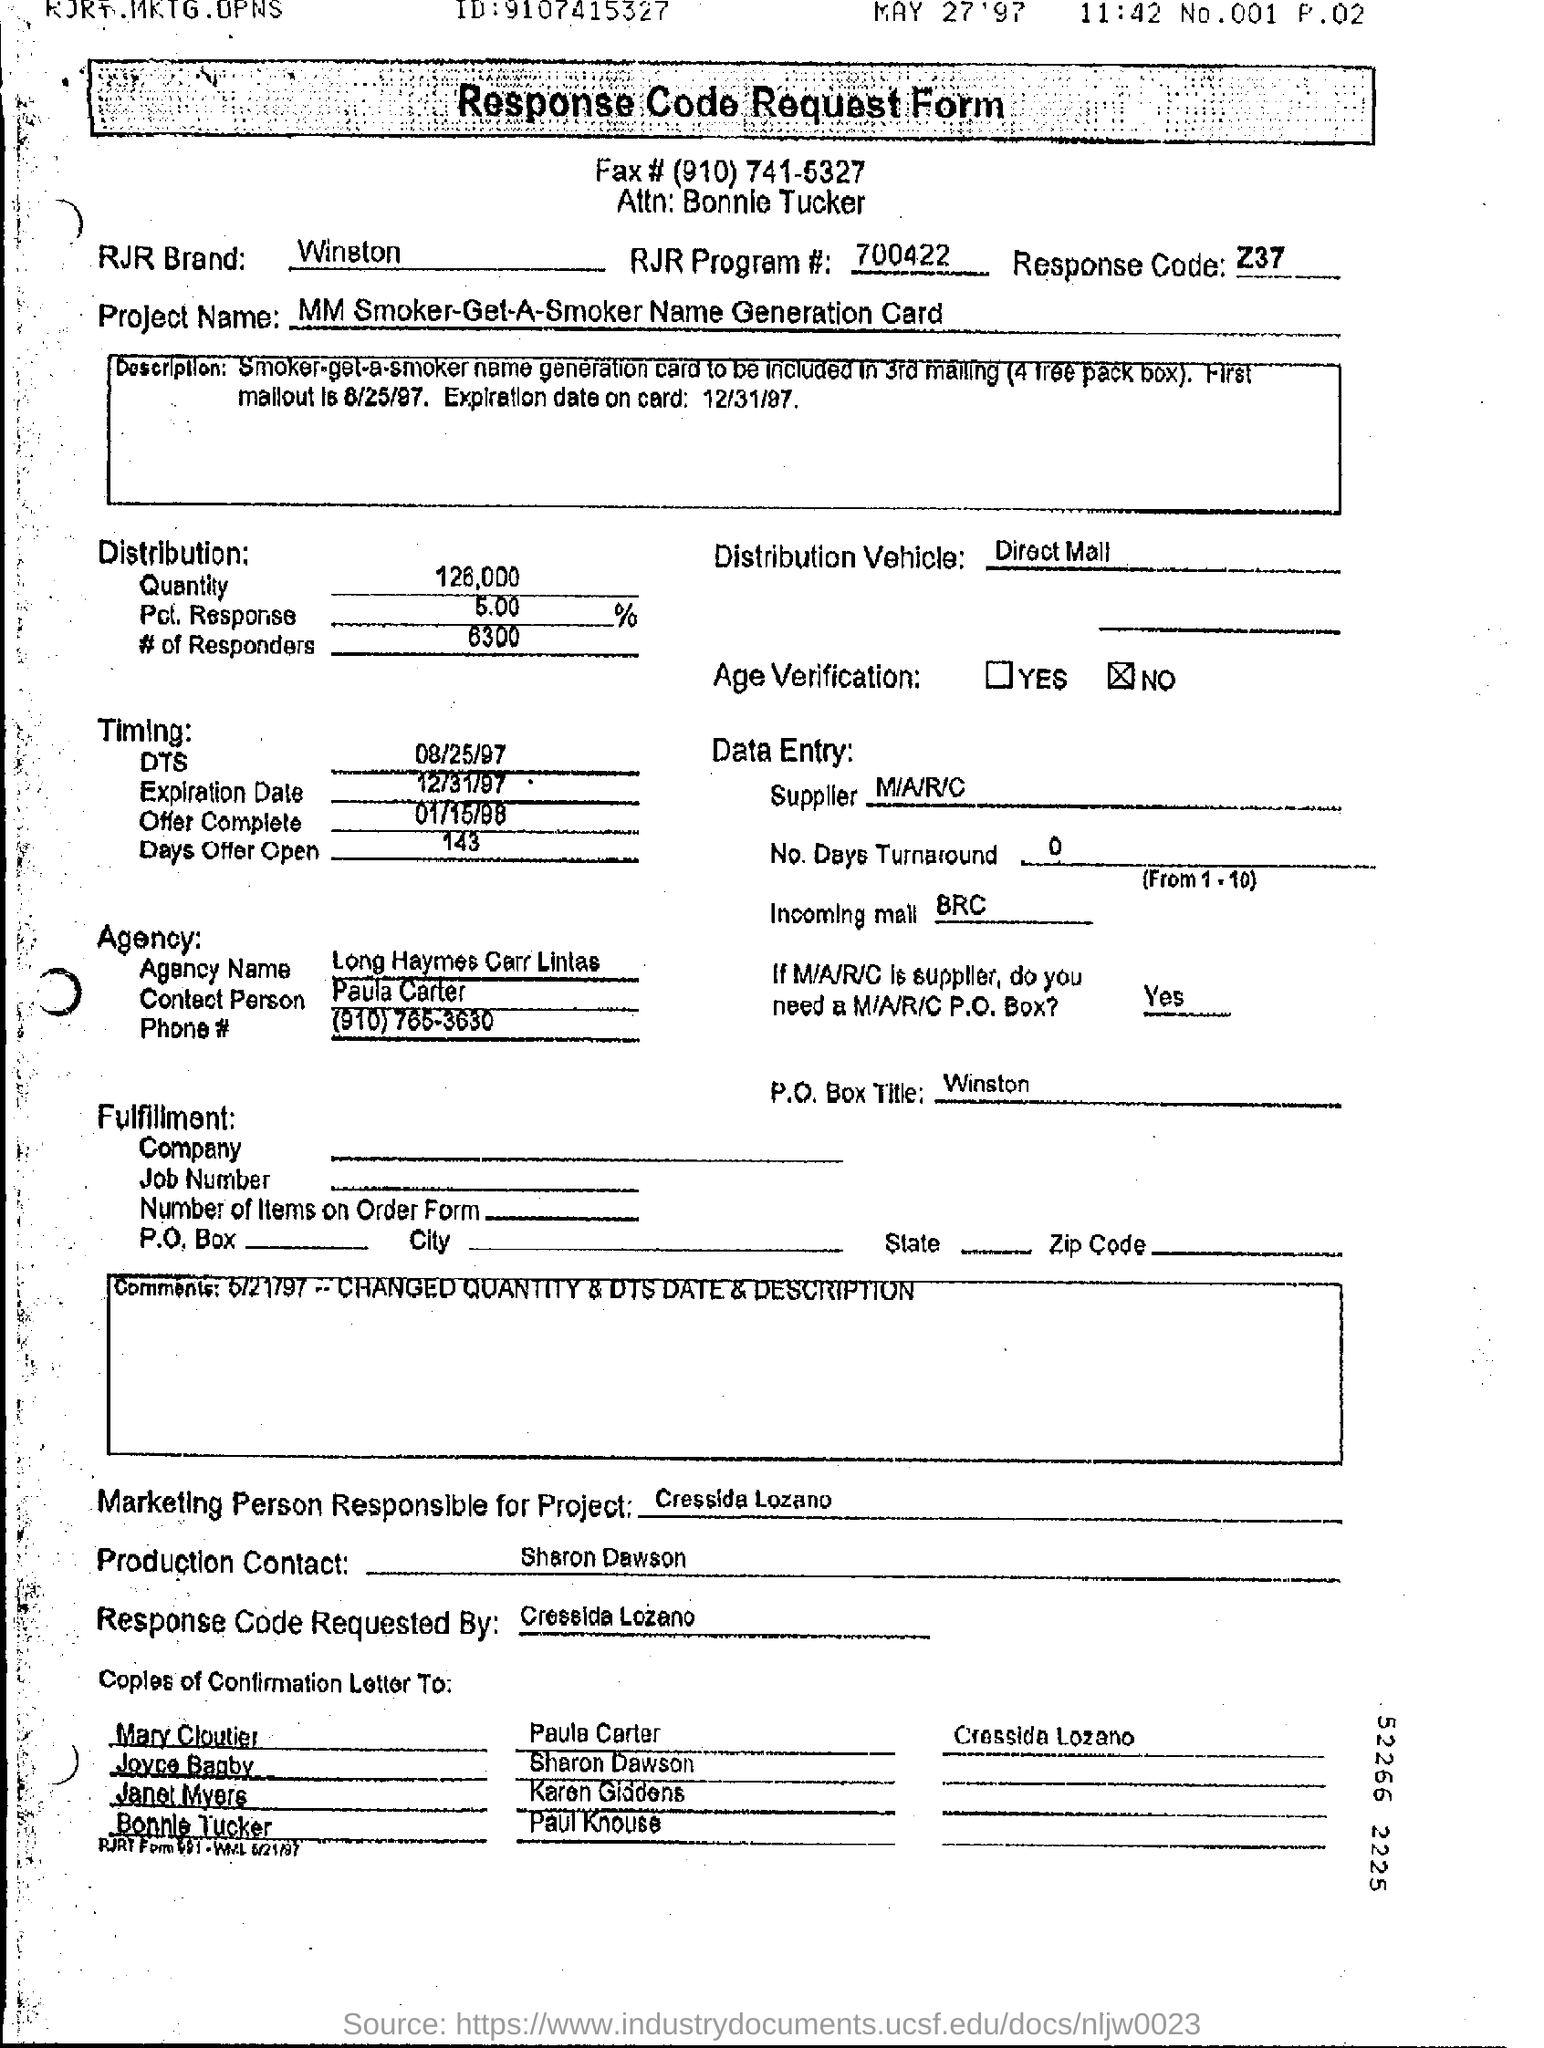Give some essential details in this illustration. On what date does the offer complete? The project is named "MM Smoker-Get-A-Smoker Name Generation Card. 